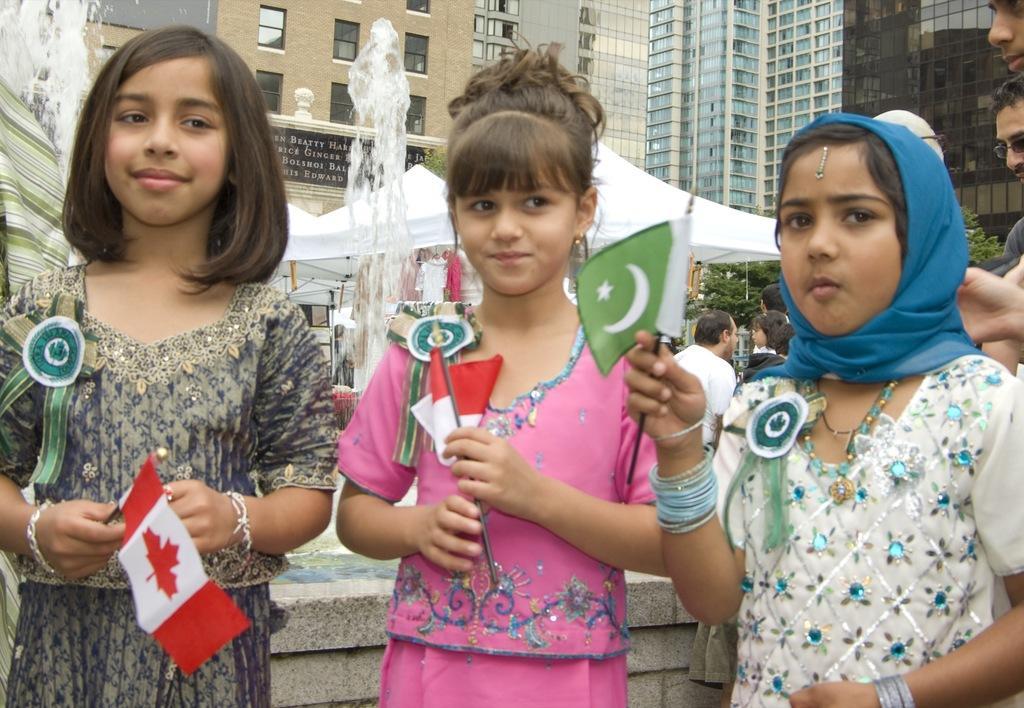Can you describe this image briefly? There are some children standing and holding flags. They have badges on the dresses. Girl on the right side is wearing a scarf, bangles and chain. In the background there are tents, fountain and buildings. On the building there are windows. On the right side some people are standing. There is a small wall behind the children. 